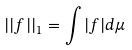Convert formula to latex. <formula><loc_0><loc_0><loc_500><loc_500>| | f | | _ { 1 } = \int | f | d \mu</formula> 